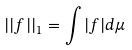Convert formula to latex. <formula><loc_0><loc_0><loc_500><loc_500>| | f | | _ { 1 } = \int | f | d \mu</formula> 